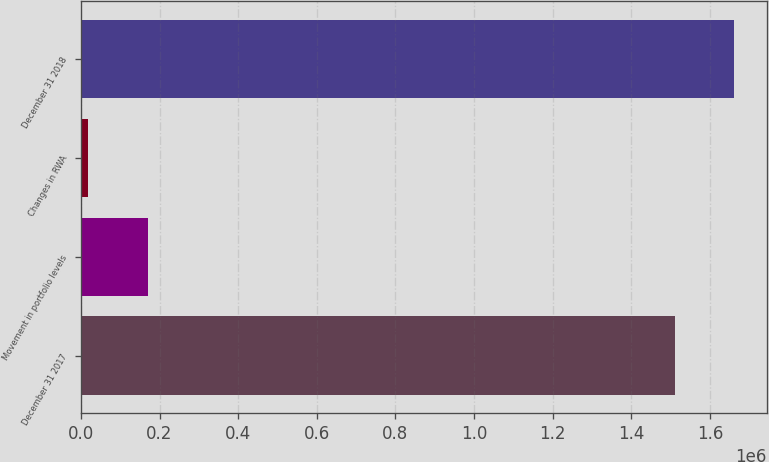Convert chart. <chart><loc_0><loc_0><loc_500><loc_500><bar_chart><fcel>December 31 2017<fcel>Movement in portfolio levels<fcel>Changes in RWA<fcel>December 31 2018<nl><fcel>1.50976e+06<fcel>170130<fcel>19154<fcel>1.66074e+06<nl></chart> 